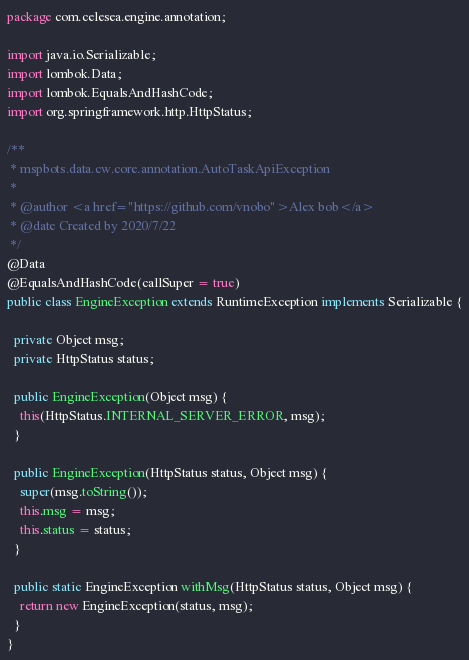Convert code to text. <code><loc_0><loc_0><loc_500><loc_500><_Java_>package com.celesea.engine.annotation;

import java.io.Serializable;
import lombok.Data;
import lombok.EqualsAndHashCode;
import org.springframework.http.HttpStatus;

/**
 * mspbots.data.cw.core.annotation.AutoTaskApiException
 *
 * @author <a href="https://github.com/vnobo">Alex bob</a>
 * @date Created by 2020/7/22
 */
@Data
@EqualsAndHashCode(callSuper = true)
public class EngineException extends RuntimeException implements Serializable {

  private Object msg;
  private HttpStatus status;

  public EngineException(Object msg) {
    this(HttpStatus.INTERNAL_SERVER_ERROR, msg);
  }

  public EngineException(HttpStatus status, Object msg) {
    super(msg.toString());
    this.msg = msg;
    this.status = status;
  }

  public static EngineException withMsg(HttpStatus status, Object msg) {
    return new EngineException(status, msg);
  }
}</code> 